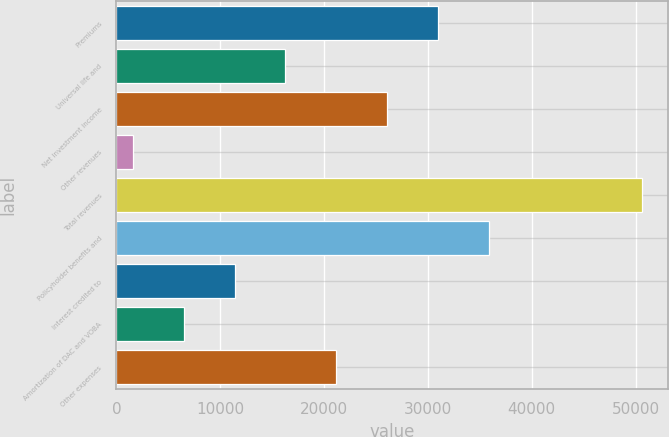Convert chart. <chart><loc_0><loc_0><loc_500><loc_500><bar_chart><fcel>Premiums<fcel>Universal life and<fcel>Net investment income<fcel>Other revenues<fcel>Total revenues<fcel>Policyholder benefits and<fcel>Interest credited to<fcel>Amortization of DAC and VOBA<fcel>Other expenses<nl><fcel>30973.6<fcel>16274.8<fcel>26074<fcel>1576<fcel>50572<fcel>35873.2<fcel>11375.2<fcel>6475.6<fcel>21174.4<nl></chart> 